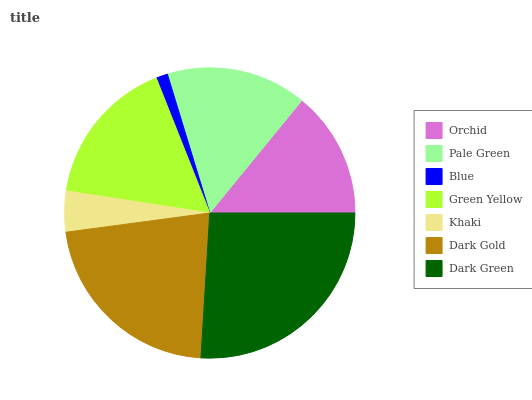Is Blue the minimum?
Answer yes or no. Yes. Is Dark Green the maximum?
Answer yes or no. Yes. Is Pale Green the minimum?
Answer yes or no. No. Is Pale Green the maximum?
Answer yes or no. No. Is Pale Green greater than Orchid?
Answer yes or no. Yes. Is Orchid less than Pale Green?
Answer yes or no. Yes. Is Orchid greater than Pale Green?
Answer yes or no. No. Is Pale Green less than Orchid?
Answer yes or no. No. Is Pale Green the high median?
Answer yes or no. Yes. Is Pale Green the low median?
Answer yes or no. Yes. Is Dark Green the high median?
Answer yes or no. No. Is Dark Green the low median?
Answer yes or no. No. 